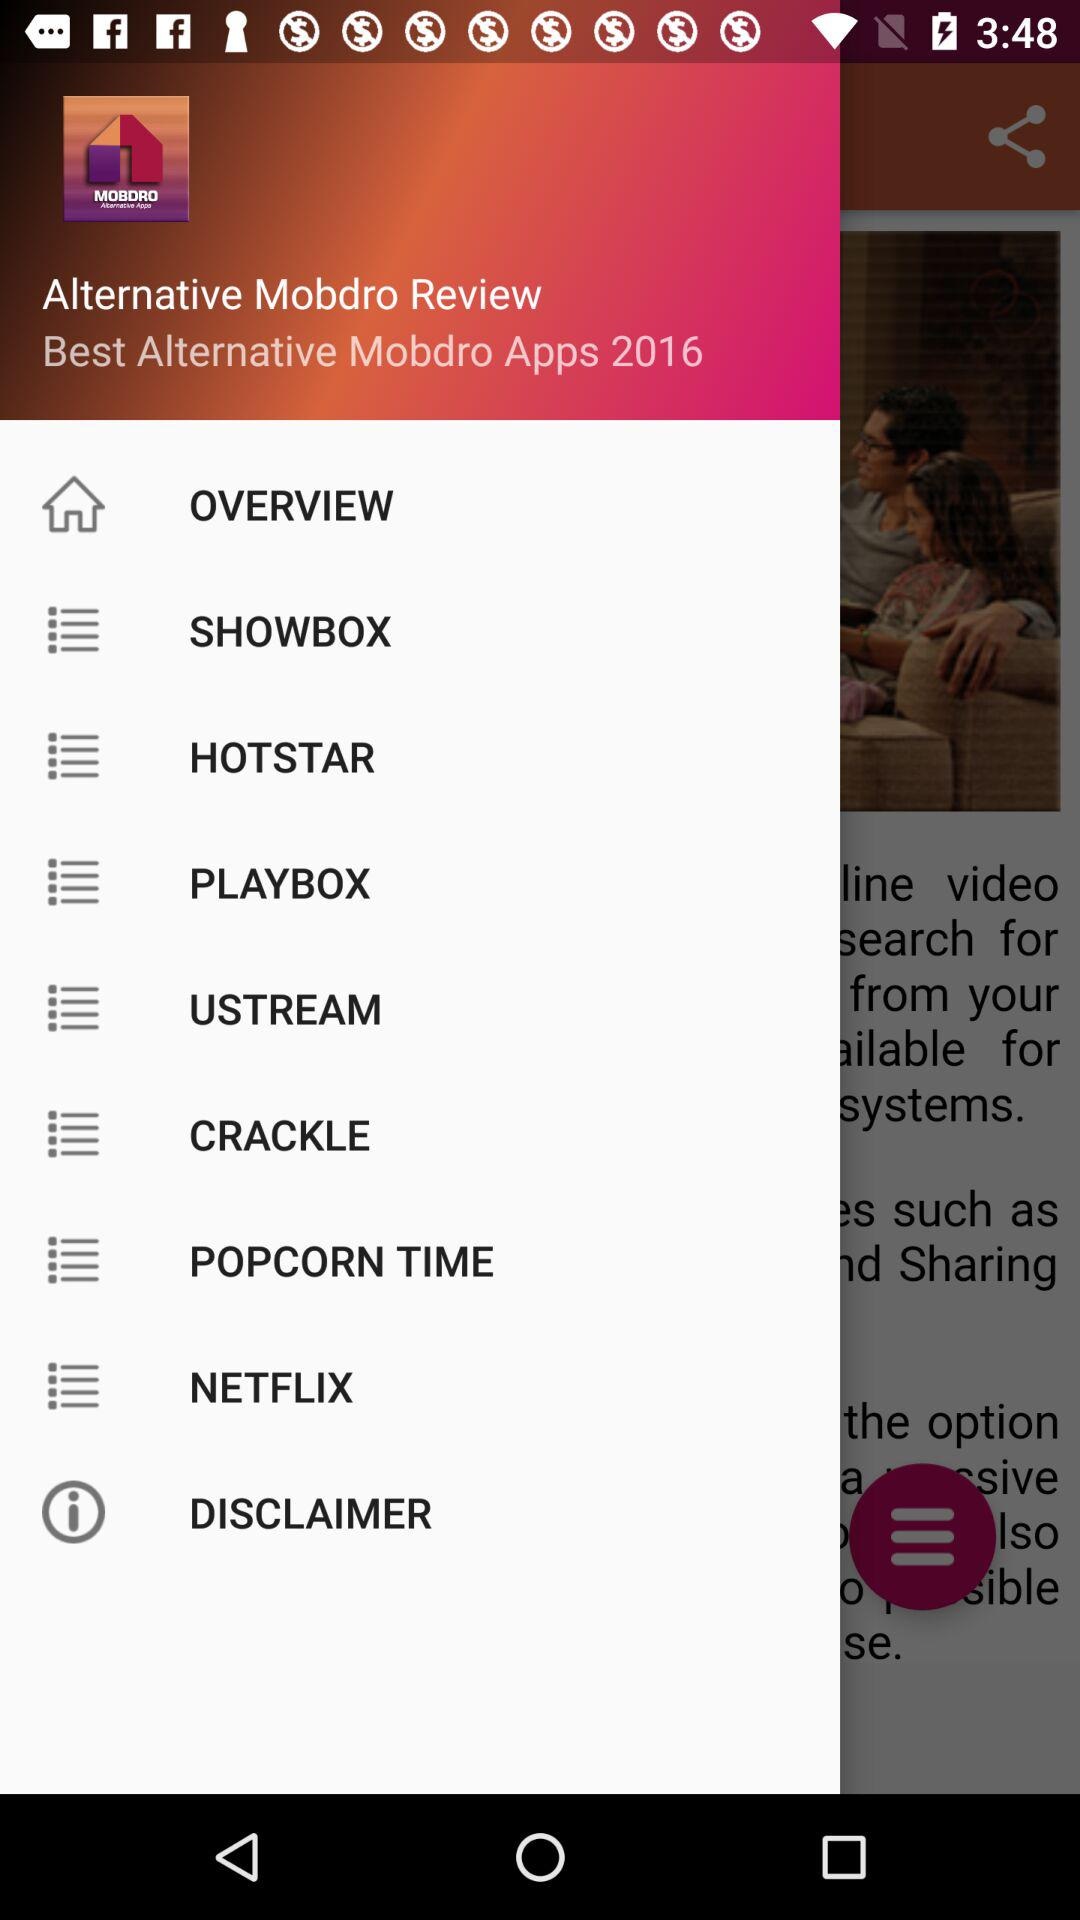What is the application name and the year? The application name is "Mobdro" and the year is 2016. 